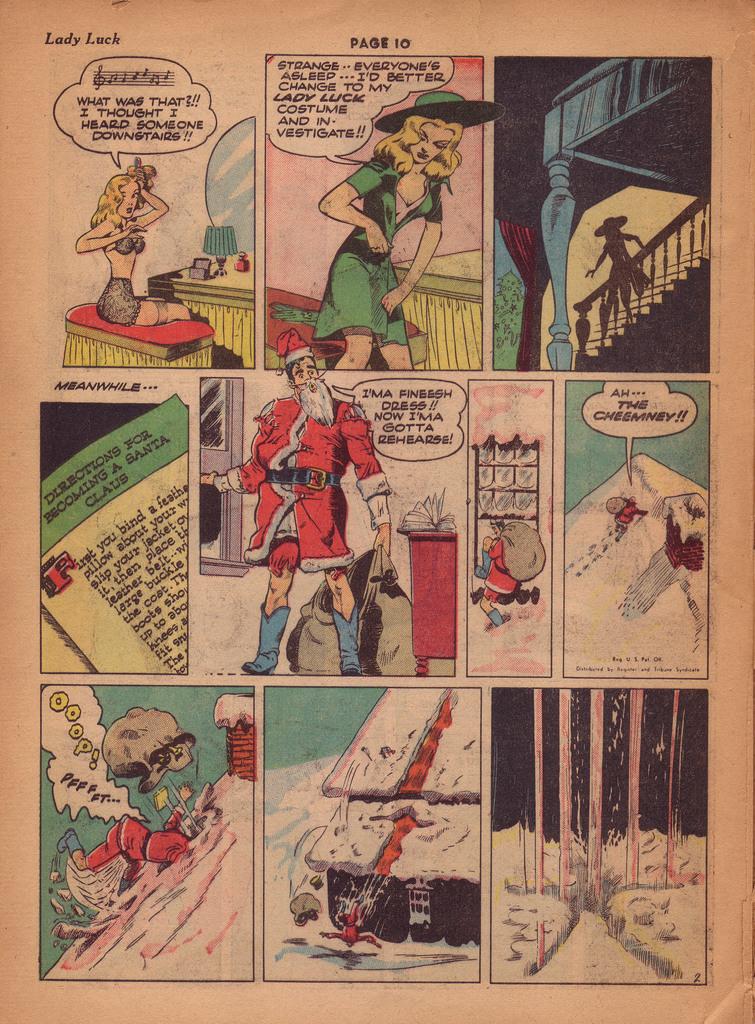What lady is mentioned here?
Keep it short and to the point. Lady luck. 